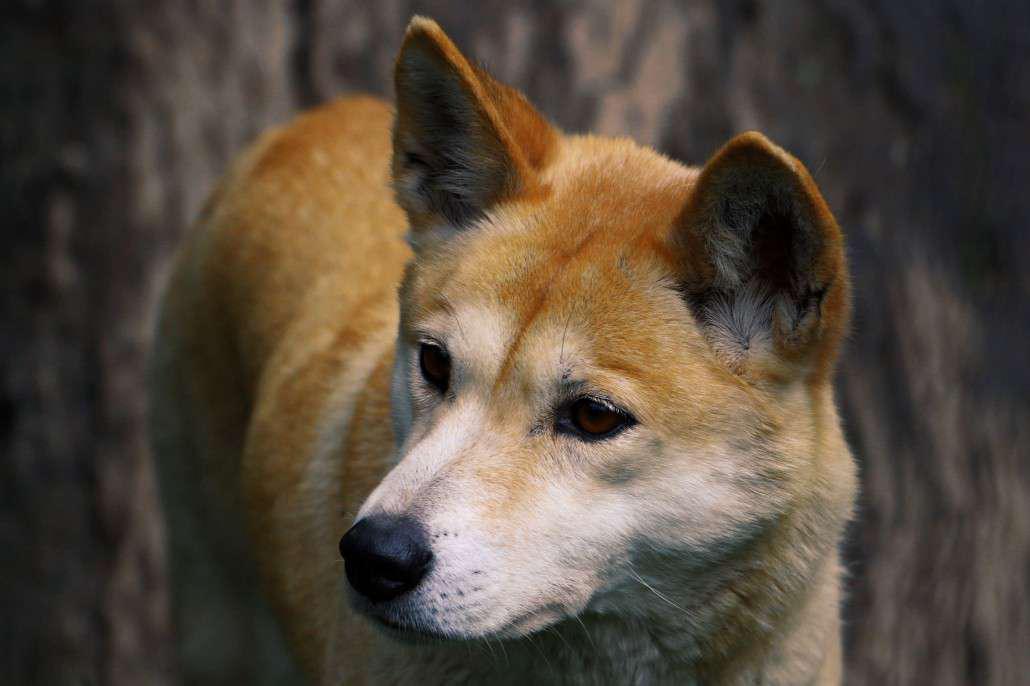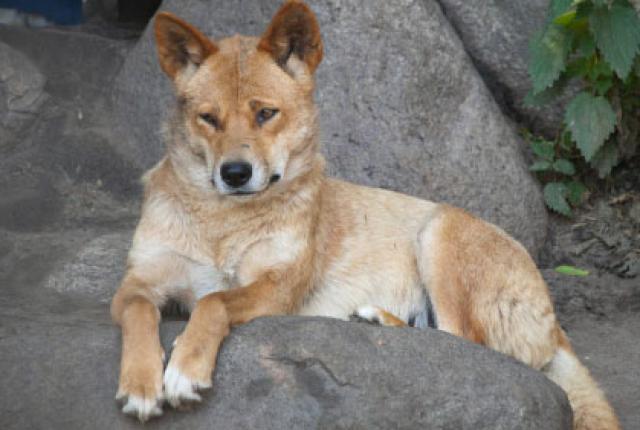The first image is the image on the left, the second image is the image on the right. Considering the images on both sides, is "Each image contains exactly one dingo, and no dog looks levelly at the camera." valid? Answer yes or no. Yes. The first image is the image on the left, the second image is the image on the right. Examine the images to the left and right. Is the description "There are two dogs in the pair of images." accurate? Answer yes or no. Yes. 